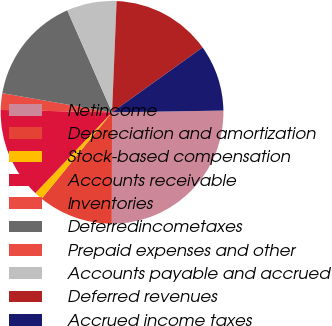Convert chart to OTSL. <chart><loc_0><loc_0><loc_500><loc_500><pie_chart><fcel>Netincome<fcel>Depreciation and amortization<fcel>Stock-based compensation<fcel>Accounts receivable<fcel>Inventories<fcel>Deferredincometaxes<fcel>Prepaid expenses and other<fcel>Accounts payable and accrued<fcel>Deferred revenues<fcel>Accrued income taxes<nl><fcel>25.29%<fcel>10.84%<fcel>1.21%<fcel>13.25%<fcel>2.41%<fcel>15.66%<fcel>0.01%<fcel>7.23%<fcel>14.45%<fcel>9.64%<nl></chart> 